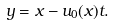<formula> <loc_0><loc_0><loc_500><loc_500>y = x - u _ { 0 } ( x ) t .</formula> 